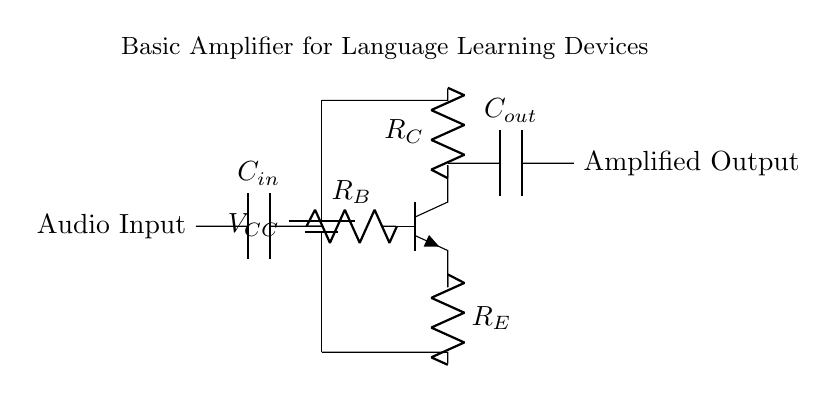What is the purpose of the transistor in this circuit? The transistor in this circuit acts as an amplifier, increasing the amplitude of the audio signal. It amplifies the input current or voltage, resulting in a stronger output signal for better audio quality.
Answer: amplifier What does the input capacitor do? The input capacitor blocks any DC component of the audio signal while allowing AC signals to pass through. This ensures that only the audio frequencies are amplified without affecting a possible DC bias.
Answer: blocks DC What components are used in the circuit? The circuit consists of a battery, an NPN transistor, resistors (for base, collector, and emitter), and two capacitors (input and output). Each component serves a specific function in the amplification process.
Answer: battery, transistor, resistors, capacitors How many resistors are in the circuit? There are three resistors: R_B (base resistor), R_C (collector resistor), and R_E (emitter resistor). Each plays a crucial role in setting the transistor's operation point and stabilizing the amplification.
Answer: three What happens to the audio signal after amplification? After amplification, the audio signal is output as a stronger signal that can drive speakers or headphones without distortion, providing clearer sound for language learning.
Answer: clearer sound What is the significance of the output capacitor? The output capacitor allows the amplified AC audio signal to pass while blocking any DC offset, protecting subsequent components from DC voltages and allowing only the intended audio to be delivered.
Answer: blocks DC offset 